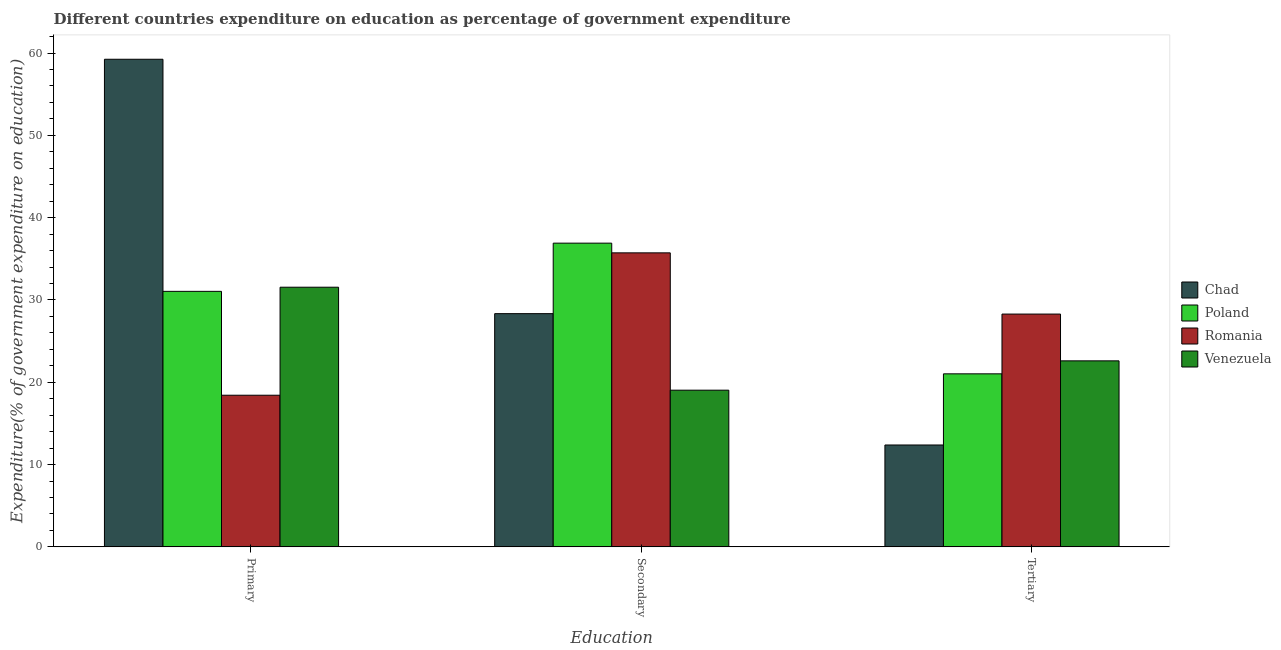Are the number of bars per tick equal to the number of legend labels?
Give a very brief answer. Yes. Are the number of bars on each tick of the X-axis equal?
Provide a short and direct response. Yes. How many bars are there on the 3rd tick from the left?
Provide a succinct answer. 4. How many bars are there on the 3rd tick from the right?
Provide a short and direct response. 4. What is the label of the 3rd group of bars from the left?
Provide a short and direct response. Tertiary. What is the expenditure on tertiary education in Poland?
Offer a terse response. 21.02. Across all countries, what is the maximum expenditure on primary education?
Offer a terse response. 59.24. Across all countries, what is the minimum expenditure on secondary education?
Keep it short and to the point. 19.04. In which country was the expenditure on tertiary education maximum?
Make the answer very short. Romania. In which country was the expenditure on secondary education minimum?
Make the answer very short. Venezuela. What is the total expenditure on tertiary education in the graph?
Keep it short and to the point. 84.28. What is the difference between the expenditure on primary education in Poland and that in Chad?
Provide a short and direct response. -28.2. What is the difference between the expenditure on tertiary education in Venezuela and the expenditure on secondary education in Poland?
Your answer should be very brief. -14.3. What is the average expenditure on tertiary education per country?
Your response must be concise. 21.07. What is the difference between the expenditure on secondary education and expenditure on tertiary education in Venezuela?
Your response must be concise. -3.56. What is the ratio of the expenditure on primary education in Poland to that in Venezuela?
Offer a terse response. 0.98. Is the expenditure on primary education in Chad less than that in Venezuela?
Offer a very short reply. No. What is the difference between the highest and the second highest expenditure on primary education?
Offer a very short reply. 27.7. What is the difference between the highest and the lowest expenditure on secondary education?
Provide a succinct answer. 17.86. What does the 2nd bar from the left in Secondary represents?
Make the answer very short. Poland. What does the 4th bar from the right in Tertiary represents?
Offer a very short reply. Chad. Is it the case that in every country, the sum of the expenditure on primary education and expenditure on secondary education is greater than the expenditure on tertiary education?
Provide a short and direct response. Yes. What is the difference between two consecutive major ticks on the Y-axis?
Make the answer very short. 10. Are the values on the major ticks of Y-axis written in scientific E-notation?
Provide a succinct answer. No. Does the graph contain any zero values?
Your answer should be very brief. No. Does the graph contain grids?
Give a very brief answer. No. Where does the legend appear in the graph?
Offer a very short reply. Center right. What is the title of the graph?
Offer a terse response. Different countries expenditure on education as percentage of government expenditure. What is the label or title of the X-axis?
Ensure brevity in your answer.  Education. What is the label or title of the Y-axis?
Ensure brevity in your answer.  Expenditure(% of government expenditure on education). What is the Expenditure(% of government expenditure on education) in Chad in Primary?
Ensure brevity in your answer.  59.24. What is the Expenditure(% of government expenditure on education) of Poland in Primary?
Provide a short and direct response. 31.04. What is the Expenditure(% of government expenditure on education) of Romania in Primary?
Provide a succinct answer. 18.42. What is the Expenditure(% of government expenditure on education) in Venezuela in Primary?
Offer a terse response. 31.55. What is the Expenditure(% of government expenditure on education) of Chad in Secondary?
Provide a succinct answer. 28.33. What is the Expenditure(% of government expenditure on education) of Poland in Secondary?
Provide a succinct answer. 36.9. What is the Expenditure(% of government expenditure on education) in Romania in Secondary?
Provide a succinct answer. 35.72. What is the Expenditure(% of government expenditure on education) in Venezuela in Secondary?
Offer a terse response. 19.04. What is the Expenditure(% of government expenditure on education) of Chad in Tertiary?
Ensure brevity in your answer.  12.38. What is the Expenditure(% of government expenditure on education) of Poland in Tertiary?
Provide a short and direct response. 21.02. What is the Expenditure(% of government expenditure on education) in Romania in Tertiary?
Provide a short and direct response. 28.28. What is the Expenditure(% of government expenditure on education) in Venezuela in Tertiary?
Offer a terse response. 22.6. Across all Education, what is the maximum Expenditure(% of government expenditure on education) in Chad?
Offer a terse response. 59.24. Across all Education, what is the maximum Expenditure(% of government expenditure on education) of Poland?
Keep it short and to the point. 36.9. Across all Education, what is the maximum Expenditure(% of government expenditure on education) of Romania?
Provide a succinct answer. 35.72. Across all Education, what is the maximum Expenditure(% of government expenditure on education) of Venezuela?
Provide a succinct answer. 31.55. Across all Education, what is the minimum Expenditure(% of government expenditure on education) of Chad?
Make the answer very short. 12.38. Across all Education, what is the minimum Expenditure(% of government expenditure on education) in Poland?
Give a very brief answer. 21.02. Across all Education, what is the minimum Expenditure(% of government expenditure on education) in Romania?
Provide a succinct answer. 18.42. Across all Education, what is the minimum Expenditure(% of government expenditure on education) of Venezuela?
Keep it short and to the point. 19.04. What is the total Expenditure(% of government expenditure on education) in Chad in the graph?
Ensure brevity in your answer.  99.95. What is the total Expenditure(% of government expenditure on education) of Poland in the graph?
Make the answer very short. 88.96. What is the total Expenditure(% of government expenditure on education) of Romania in the graph?
Keep it short and to the point. 82.42. What is the total Expenditure(% of government expenditure on education) in Venezuela in the graph?
Provide a succinct answer. 73.18. What is the difference between the Expenditure(% of government expenditure on education) of Chad in Primary and that in Secondary?
Provide a succinct answer. 30.91. What is the difference between the Expenditure(% of government expenditure on education) of Poland in Primary and that in Secondary?
Your response must be concise. -5.86. What is the difference between the Expenditure(% of government expenditure on education) in Romania in Primary and that in Secondary?
Give a very brief answer. -17.3. What is the difference between the Expenditure(% of government expenditure on education) in Venezuela in Primary and that in Secondary?
Offer a terse response. 12.51. What is the difference between the Expenditure(% of government expenditure on education) in Chad in Primary and that in Tertiary?
Your answer should be very brief. 46.86. What is the difference between the Expenditure(% of government expenditure on education) of Poland in Primary and that in Tertiary?
Provide a succinct answer. 10.02. What is the difference between the Expenditure(% of government expenditure on education) in Romania in Primary and that in Tertiary?
Your answer should be very brief. -9.86. What is the difference between the Expenditure(% of government expenditure on education) of Venezuela in Primary and that in Tertiary?
Make the answer very short. 8.95. What is the difference between the Expenditure(% of government expenditure on education) of Chad in Secondary and that in Tertiary?
Give a very brief answer. 15.96. What is the difference between the Expenditure(% of government expenditure on education) of Poland in Secondary and that in Tertiary?
Provide a short and direct response. 15.88. What is the difference between the Expenditure(% of government expenditure on education) in Romania in Secondary and that in Tertiary?
Offer a very short reply. 7.44. What is the difference between the Expenditure(% of government expenditure on education) of Venezuela in Secondary and that in Tertiary?
Make the answer very short. -3.56. What is the difference between the Expenditure(% of government expenditure on education) in Chad in Primary and the Expenditure(% of government expenditure on education) in Poland in Secondary?
Provide a succinct answer. 22.34. What is the difference between the Expenditure(% of government expenditure on education) in Chad in Primary and the Expenditure(% of government expenditure on education) in Romania in Secondary?
Your answer should be very brief. 23.52. What is the difference between the Expenditure(% of government expenditure on education) of Chad in Primary and the Expenditure(% of government expenditure on education) of Venezuela in Secondary?
Offer a terse response. 40.21. What is the difference between the Expenditure(% of government expenditure on education) in Poland in Primary and the Expenditure(% of government expenditure on education) in Romania in Secondary?
Your answer should be very brief. -4.68. What is the difference between the Expenditure(% of government expenditure on education) of Poland in Primary and the Expenditure(% of government expenditure on education) of Venezuela in Secondary?
Give a very brief answer. 12.01. What is the difference between the Expenditure(% of government expenditure on education) in Romania in Primary and the Expenditure(% of government expenditure on education) in Venezuela in Secondary?
Your response must be concise. -0.61. What is the difference between the Expenditure(% of government expenditure on education) in Chad in Primary and the Expenditure(% of government expenditure on education) in Poland in Tertiary?
Your response must be concise. 38.22. What is the difference between the Expenditure(% of government expenditure on education) of Chad in Primary and the Expenditure(% of government expenditure on education) of Romania in Tertiary?
Your answer should be very brief. 30.96. What is the difference between the Expenditure(% of government expenditure on education) in Chad in Primary and the Expenditure(% of government expenditure on education) in Venezuela in Tertiary?
Offer a very short reply. 36.64. What is the difference between the Expenditure(% of government expenditure on education) in Poland in Primary and the Expenditure(% of government expenditure on education) in Romania in Tertiary?
Your answer should be very brief. 2.76. What is the difference between the Expenditure(% of government expenditure on education) in Poland in Primary and the Expenditure(% of government expenditure on education) in Venezuela in Tertiary?
Provide a short and direct response. 8.44. What is the difference between the Expenditure(% of government expenditure on education) of Romania in Primary and the Expenditure(% of government expenditure on education) of Venezuela in Tertiary?
Offer a very short reply. -4.18. What is the difference between the Expenditure(% of government expenditure on education) of Chad in Secondary and the Expenditure(% of government expenditure on education) of Poland in Tertiary?
Provide a succinct answer. 7.31. What is the difference between the Expenditure(% of government expenditure on education) in Chad in Secondary and the Expenditure(% of government expenditure on education) in Romania in Tertiary?
Give a very brief answer. 0.05. What is the difference between the Expenditure(% of government expenditure on education) of Chad in Secondary and the Expenditure(% of government expenditure on education) of Venezuela in Tertiary?
Offer a very short reply. 5.73. What is the difference between the Expenditure(% of government expenditure on education) of Poland in Secondary and the Expenditure(% of government expenditure on education) of Romania in Tertiary?
Offer a terse response. 8.62. What is the difference between the Expenditure(% of government expenditure on education) of Poland in Secondary and the Expenditure(% of government expenditure on education) of Venezuela in Tertiary?
Offer a terse response. 14.3. What is the difference between the Expenditure(% of government expenditure on education) of Romania in Secondary and the Expenditure(% of government expenditure on education) of Venezuela in Tertiary?
Provide a succinct answer. 13.12. What is the average Expenditure(% of government expenditure on education) of Chad per Education?
Offer a terse response. 33.32. What is the average Expenditure(% of government expenditure on education) of Poland per Education?
Provide a short and direct response. 29.65. What is the average Expenditure(% of government expenditure on education) in Romania per Education?
Provide a succinct answer. 27.47. What is the average Expenditure(% of government expenditure on education) in Venezuela per Education?
Keep it short and to the point. 24.39. What is the difference between the Expenditure(% of government expenditure on education) in Chad and Expenditure(% of government expenditure on education) in Poland in Primary?
Keep it short and to the point. 28.2. What is the difference between the Expenditure(% of government expenditure on education) in Chad and Expenditure(% of government expenditure on education) in Romania in Primary?
Keep it short and to the point. 40.82. What is the difference between the Expenditure(% of government expenditure on education) in Chad and Expenditure(% of government expenditure on education) in Venezuela in Primary?
Your response must be concise. 27.7. What is the difference between the Expenditure(% of government expenditure on education) in Poland and Expenditure(% of government expenditure on education) in Romania in Primary?
Your response must be concise. 12.62. What is the difference between the Expenditure(% of government expenditure on education) of Poland and Expenditure(% of government expenditure on education) of Venezuela in Primary?
Provide a short and direct response. -0.5. What is the difference between the Expenditure(% of government expenditure on education) of Romania and Expenditure(% of government expenditure on education) of Venezuela in Primary?
Offer a terse response. -13.12. What is the difference between the Expenditure(% of government expenditure on education) of Chad and Expenditure(% of government expenditure on education) of Poland in Secondary?
Your answer should be compact. -8.56. What is the difference between the Expenditure(% of government expenditure on education) of Chad and Expenditure(% of government expenditure on education) of Romania in Secondary?
Keep it short and to the point. -7.39. What is the difference between the Expenditure(% of government expenditure on education) in Chad and Expenditure(% of government expenditure on education) in Venezuela in Secondary?
Provide a short and direct response. 9.3. What is the difference between the Expenditure(% of government expenditure on education) in Poland and Expenditure(% of government expenditure on education) in Romania in Secondary?
Ensure brevity in your answer.  1.18. What is the difference between the Expenditure(% of government expenditure on education) of Poland and Expenditure(% of government expenditure on education) of Venezuela in Secondary?
Keep it short and to the point. 17.86. What is the difference between the Expenditure(% of government expenditure on education) in Romania and Expenditure(% of government expenditure on education) in Venezuela in Secondary?
Offer a terse response. 16.68. What is the difference between the Expenditure(% of government expenditure on education) in Chad and Expenditure(% of government expenditure on education) in Poland in Tertiary?
Offer a terse response. -8.64. What is the difference between the Expenditure(% of government expenditure on education) in Chad and Expenditure(% of government expenditure on education) in Romania in Tertiary?
Provide a short and direct response. -15.91. What is the difference between the Expenditure(% of government expenditure on education) of Chad and Expenditure(% of government expenditure on education) of Venezuela in Tertiary?
Your answer should be compact. -10.22. What is the difference between the Expenditure(% of government expenditure on education) in Poland and Expenditure(% of government expenditure on education) in Romania in Tertiary?
Offer a very short reply. -7.26. What is the difference between the Expenditure(% of government expenditure on education) in Poland and Expenditure(% of government expenditure on education) in Venezuela in Tertiary?
Make the answer very short. -1.58. What is the difference between the Expenditure(% of government expenditure on education) in Romania and Expenditure(% of government expenditure on education) in Venezuela in Tertiary?
Provide a succinct answer. 5.68. What is the ratio of the Expenditure(% of government expenditure on education) in Chad in Primary to that in Secondary?
Make the answer very short. 2.09. What is the ratio of the Expenditure(% of government expenditure on education) in Poland in Primary to that in Secondary?
Give a very brief answer. 0.84. What is the ratio of the Expenditure(% of government expenditure on education) in Romania in Primary to that in Secondary?
Your answer should be very brief. 0.52. What is the ratio of the Expenditure(% of government expenditure on education) of Venezuela in Primary to that in Secondary?
Provide a succinct answer. 1.66. What is the ratio of the Expenditure(% of government expenditure on education) of Chad in Primary to that in Tertiary?
Your answer should be compact. 4.79. What is the ratio of the Expenditure(% of government expenditure on education) of Poland in Primary to that in Tertiary?
Make the answer very short. 1.48. What is the ratio of the Expenditure(% of government expenditure on education) of Romania in Primary to that in Tertiary?
Your answer should be compact. 0.65. What is the ratio of the Expenditure(% of government expenditure on education) of Venezuela in Primary to that in Tertiary?
Keep it short and to the point. 1.4. What is the ratio of the Expenditure(% of government expenditure on education) of Chad in Secondary to that in Tertiary?
Keep it short and to the point. 2.29. What is the ratio of the Expenditure(% of government expenditure on education) of Poland in Secondary to that in Tertiary?
Your response must be concise. 1.76. What is the ratio of the Expenditure(% of government expenditure on education) of Romania in Secondary to that in Tertiary?
Your answer should be compact. 1.26. What is the ratio of the Expenditure(% of government expenditure on education) in Venezuela in Secondary to that in Tertiary?
Offer a terse response. 0.84. What is the difference between the highest and the second highest Expenditure(% of government expenditure on education) of Chad?
Provide a short and direct response. 30.91. What is the difference between the highest and the second highest Expenditure(% of government expenditure on education) in Poland?
Ensure brevity in your answer.  5.86. What is the difference between the highest and the second highest Expenditure(% of government expenditure on education) in Romania?
Offer a terse response. 7.44. What is the difference between the highest and the second highest Expenditure(% of government expenditure on education) in Venezuela?
Keep it short and to the point. 8.95. What is the difference between the highest and the lowest Expenditure(% of government expenditure on education) of Chad?
Give a very brief answer. 46.86. What is the difference between the highest and the lowest Expenditure(% of government expenditure on education) in Poland?
Your answer should be very brief. 15.88. What is the difference between the highest and the lowest Expenditure(% of government expenditure on education) in Romania?
Offer a very short reply. 17.3. What is the difference between the highest and the lowest Expenditure(% of government expenditure on education) in Venezuela?
Keep it short and to the point. 12.51. 